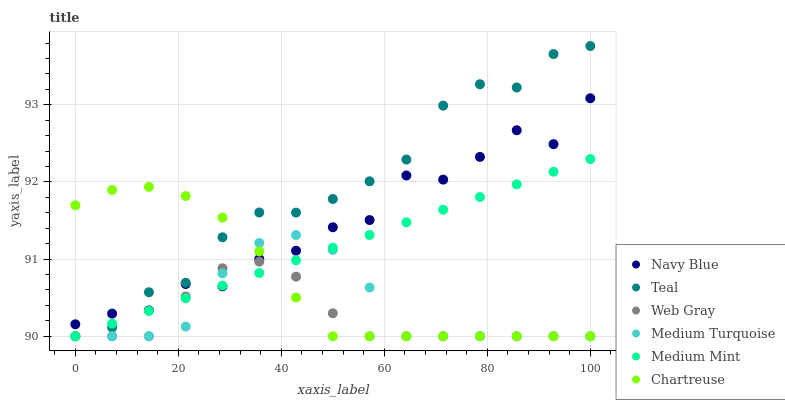Does Web Gray have the minimum area under the curve?
Answer yes or no. Yes. Does Teal have the maximum area under the curve?
Answer yes or no. Yes. Does Teal have the minimum area under the curve?
Answer yes or no. No. Does Web Gray have the maximum area under the curve?
Answer yes or no. No. Is Medium Mint the smoothest?
Answer yes or no. Yes. Is Navy Blue the roughest?
Answer yes or no. Yes. Is Web Gray the smoothest?
Answer yes or no. No. Is Web Gray the roughest?
Answer yes or no. No. Does Medium Mint have the lowest value?
Answer yes or no. Yes. Does Navy Blue have the lowest value?
Answer yes or no. No. Does Teal have the highest value?
Answer yes or no. Yes. Does Web Gray have the highest value?
Answer yes or no. No. Does Medium Mint intersect Teal?
Answer yes or no. Yes. Is Medium Mint less than Teal?
Answer yes or no. No. Is Medium Mint greater than Teal?
Answer yes or no. No. 